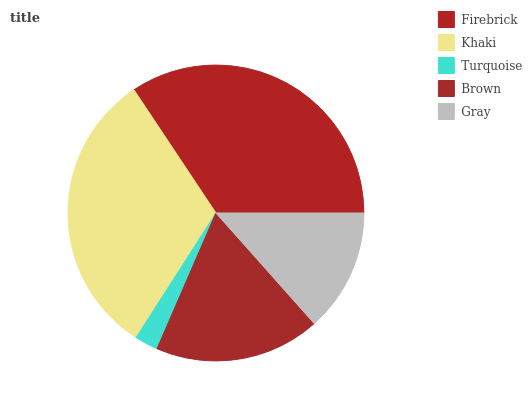Is Turquoise the minimum?
Answer yes or no. Yes. Is Firebrick the maximum?
Answer yes or no. Yes. Is Khaki the minimum?
Answer yes or no. No. Is Khaki the maximum?
Answer yes or no. No. Is Firebrick greater than Khaki?
Answer yes or no. Yes. Is Khaki less than Firebrick?
Answer yes or no. Yes. Is Khaki greater than Firebrick?
Answer yes or no. No. Is Firebrick less than Khaki?
Answer yes or no. No. Is Brown the high median?
Answer yes or no. Yes. Is Brown the low median?
Answer yes or no. Yes. Is Gray the high median?
Answer yes or no. No. Is Khaki the low median?
Answer yes or no. No. 